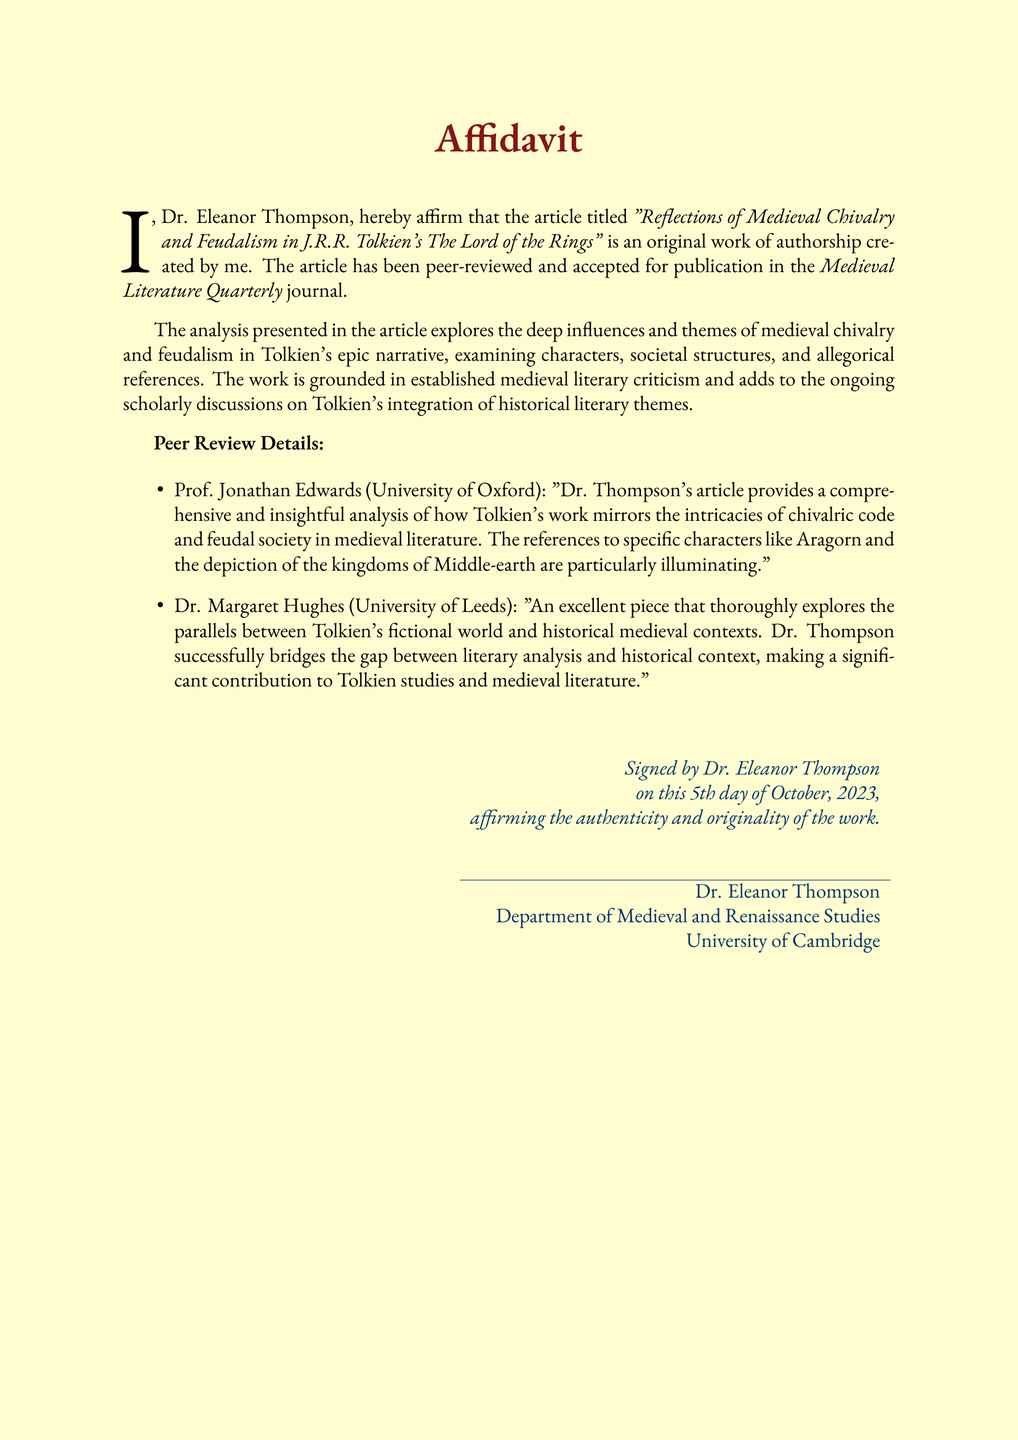What is the title of the article? The title of the article is explicitly mentioned in the document.
Answer: "Reflections of Medieval Chivalry and Feudalism in J.R.R. Tolkien's The Lord of the Rings" Who is the author of the affidavit? The affidavit states the author's name clearly.
Answer: Dr. Eleanor Thompson What is the publication journal's name? The document specifies the journal where the article is published.
Answer: Medieval Literature Quarterly Who provided a peer review for the article? The document lists individuals who peer-reviewed the article.
Answer: Prof. Jonathan Edwards and Dr. Margaret Hughes What date was the affidavit signed? The affidavit includes the specific date of signing.
Answer: 5th day of October, 2023 What is the main theme of the article? The affidavit summarizes the focus of the article.
Answer: medieval chivalry and feudalism Which university is Dr. Eleanor Thompson affiliated with? The document provides the author's institutional affiliation.
Answer: University of Cambridge What type of document is this? The format and content of the document clearly indicate its nature.
Answer: Affidavit 